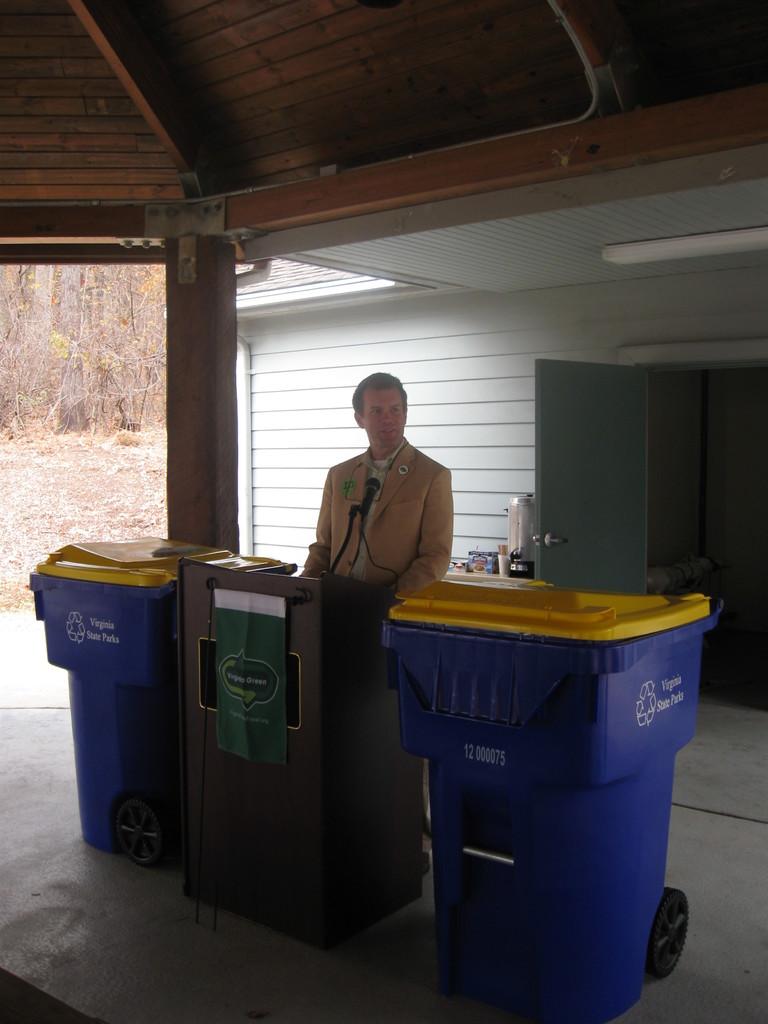What state does this take place in?
Keep it short and to the point. Virginia. What are the numbers written on the front of the blue trash can on the right?
Provide a succinct answer. 12 000075. 